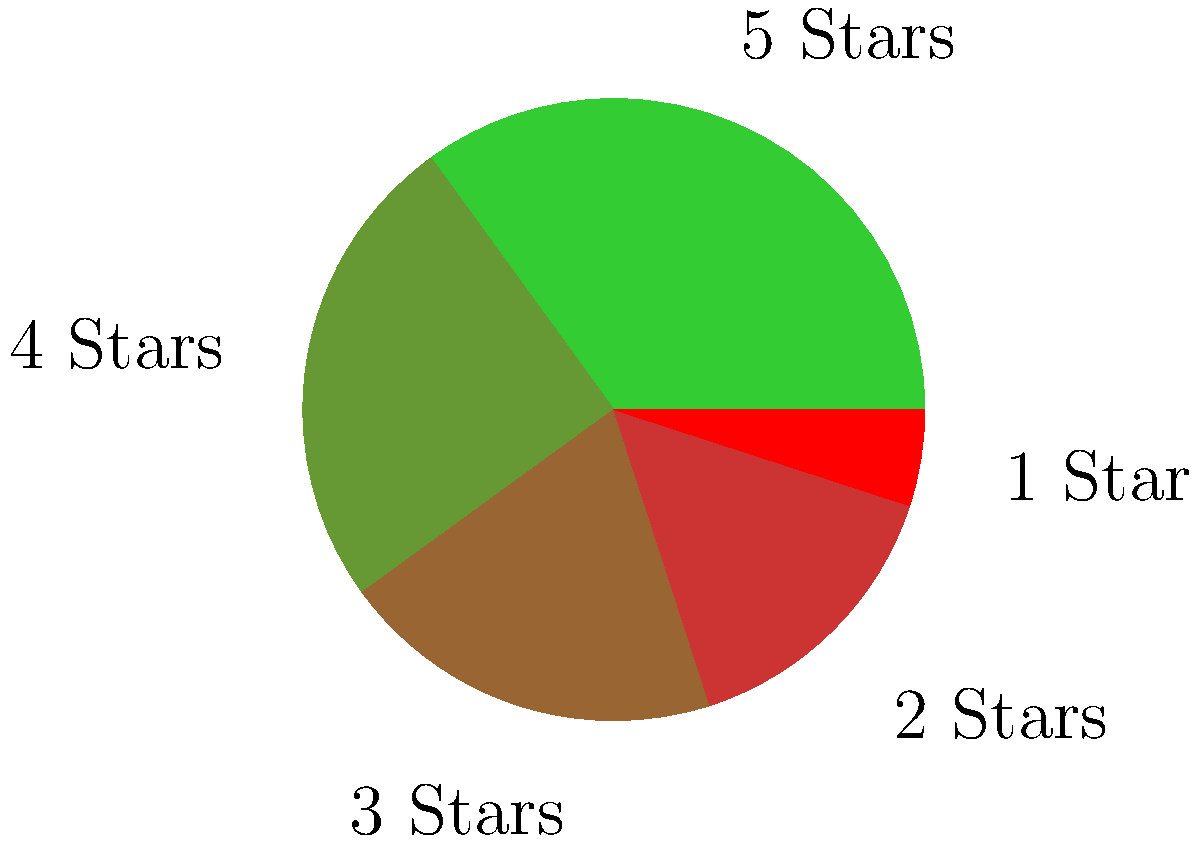As a book reviewer relying on publishing professionals' recommendations, you've compiled ratings for your latest blog post. The pie chart shows the distribution of book review ratings. What percentage of reviews received 4 stars or higher? To solve this problem, we need to follow these steps:

1. Identify the slices representing 4-star and 5-star ratings:
   - 5 Stars: 35%
   - 4 Stars: 25%

2. Add these percentages together:
   $35\% + 25\% = 60\%$

The sum of these two slices represents the percentage of reviews that received 4 stars or higher.

This approach aligns with a book reviewer's task of summarizing rating distributions, which is crucial when relying on publishing professionals' recommendations for blog content.
Answer: 60% 